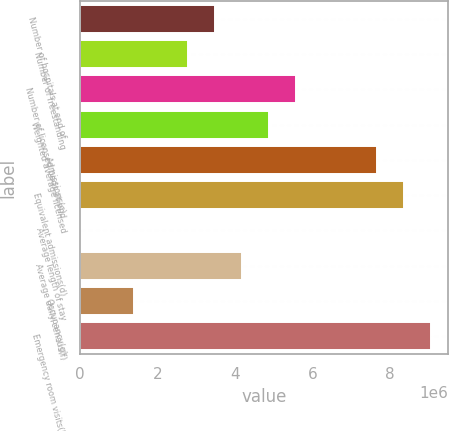Convert chart. <chart><loc_0><loc_0><loc_500><loc_500><bar_chart><fcel>Number of hospitals at end of<fcel>Number of freestanding<fcel>Number of licensed beds at end<fcel>Weighted average licensed<fcel>Admissions(c)<fcel>Equivalent admissions(d)<fcel>Average length of stay<fcel>Average daily census(f)<fcel>Occupancy(g)<fcel>Emergency room visits(h)<nl><fcel>3.48405e+06<fcel>2.78724e+06<fcel>5.57448e+06<fcel>4.87767e+06<fcel>7.66491e+06<fcel>8.36172e+06<fcel>4.8<fcel>4.18086e+06<fcel>1.39362e+06<fcel>9.05853e+06<nl></chart> 